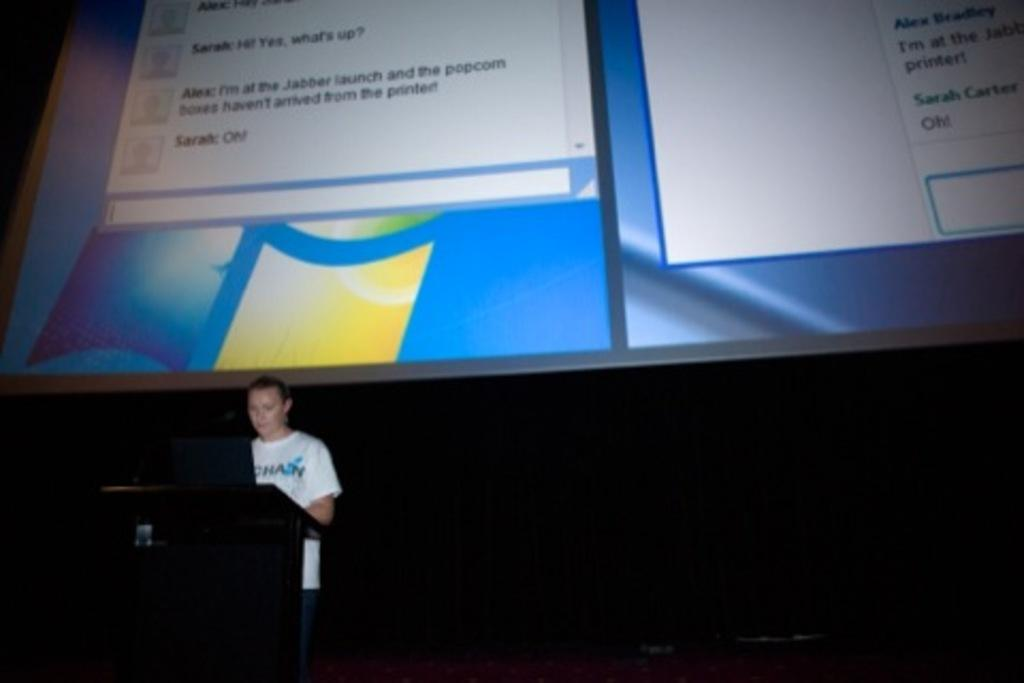Who is present in the image? There is a man in the image. What is the man's position in relation to the table? The man is standing in front of a table. What electronic device is on the table? There is a laptop on the table. What is displayed on the screen behind the man? There is a screen displaying images behind the man. What advice does the man give about tax preparation in the image? There is no indication in the image that the man is giving advice about tax preparation. 